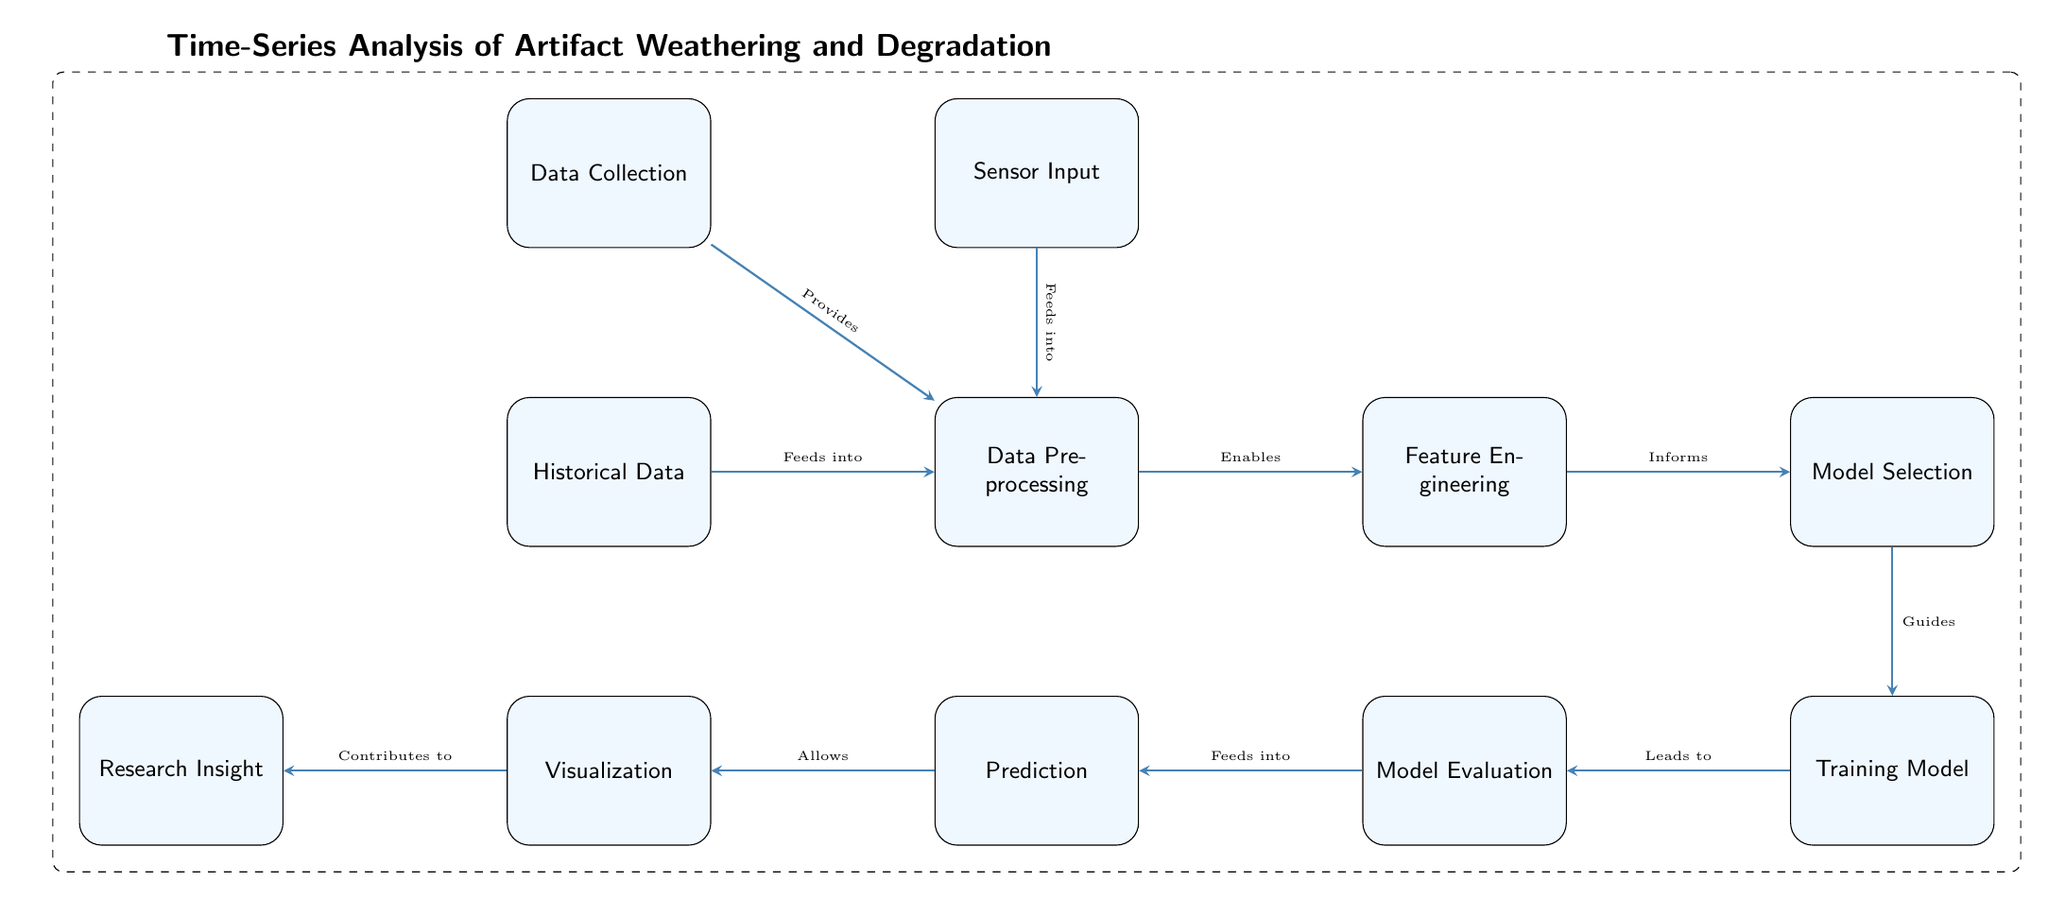What is the first node in the diagram? The first node is labeled "Data Collection", which is the starting point of the process depicted in the diagram.
Answer: Data Collection How many nodes are present in the diagram? The diagram features a total of 11 nodes, each representing a distinct step in the process of time-series analysis.
Answer: 11 Which node does "Sensor Input" feed into? "Sensor Input" feeds directly into the "Data Preprocessing" node, indicating that it contributes data for processing.
Answer: Data Preprocessing What relationship exists between "Model Selection" and "Training Model"? "Model Selection" guides the "Training Model" process, highlighting that the model chosen influences how the model is trained.
Answer: Guides What is the last node in the flow? The last node in the diagram is "Research Insight", which signifies the culmination of the analysis process leading to insights about the artifacts.
Answer: Research Insight Which node directly allows for "Visualization"? The node that allows for "Visualization" is "Prediction", denoting that predictions must be made before visualizations can be created.
Answer: Prediction What type of data does the "Data Collection" node encompass? The "Data Collection" node encompasses both sensor input and historical data, as it gathers all relevant data types for analysis.
Answer: Sensor Input and Historical Data Which node enables "Feature Engineering"? The node that enables "Feature Engineering" is "Data Preprocessing", emphasizing that data needs to be processed before features can be engineered.
Answer: Data Preprocessing What follows after "Model Evaluation"? After "Model Evaluation", the process flows to "Prediction", indicating that model evaluations lead to making predictions based on the trained model.
Answer: Prediction 